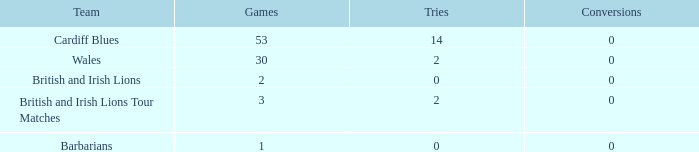What is the average number of conversions for the Cardiff Blues with less than 14 tries? None. 